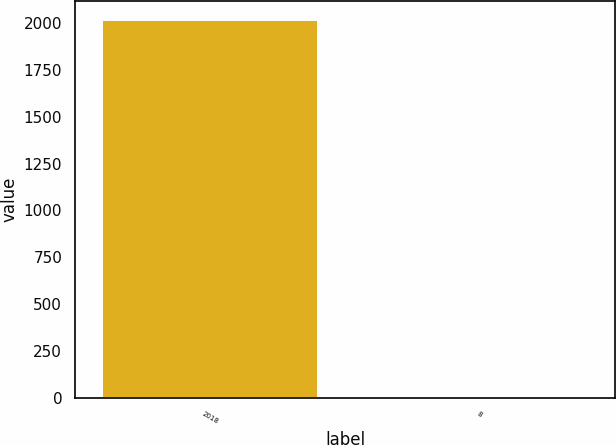<chart> <loc_0><loc_0><loc_500><loc_500><bar_chart><fcel>2018<fcel>8<nl><fcel>2016<fcel>6<nl></chart> 